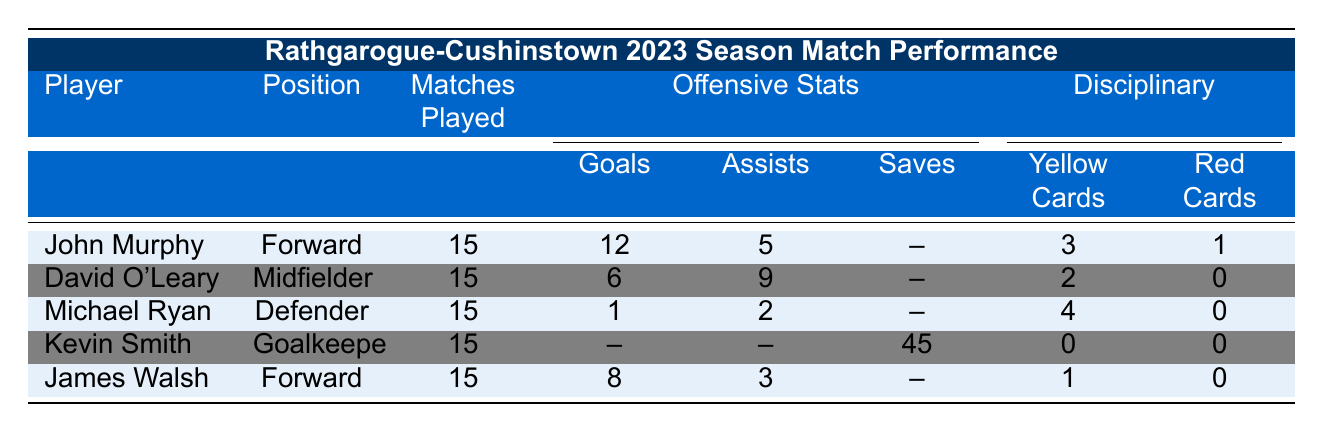What is the total number of goals scored by Rathgarogue-Cushinstown players? To find the total goals, we sum the number of goals from all players: John Murphy (12) + David O'Leary (6) + Michael Ryan (1) + James Walsh (8) = 27. Kevin Smith is a goalkeeper and does not score goals.
Answer: 27 Who received the most yellow cards in the team? Looking at the yellow cards for each player: John Murphy (3), David O'Leary (2), Michael Ryan (4), Kevin Smith (0), and James Walsh (1). Michael Ryan has the highest number with 4 yellow cards.
Answer: Michael Ryan How many assists does David O'Leary have compared to James Walsh? David O'Leary has 9 assists, while James Walsh has 3 assists. To compare, 9 - 3 = 6, so David has 6 more assists.
Answer: 6 What percentage of matches did John Murphy receive red cards in? John Murphy played 15 matches and received 1 red card. The percentage is calculated as (1 red card / 15 matches) * 100 = 6.67%.
Answer: 6.67% Did any player achieve a clean sheet? A clean sheet is only relevant for goalkeepers. Kevin Smith is the goalkeeper who achieved 5 clean sheets while playing 15 matches. Therefore, yes, he achieved clean sheets.
Answer: Yes Which player has the highest number of assists and how many? The highest assists go to David O'Leary with 9 assists. Comparing all players: John Murphy (5), David O'Leary (9), Michael Ryan (2), Kevin Smith (N/A for assists), and James Walsh (3), 9 is the highest.
Answer: 9 How many matches were played by the Defender Michael Ryan? According to the table, Michael Ryan played 15 matches.
Answer: 15 What is the ratio of goals to assists for John Murphy? John Murphy scored 12 goals and made 5 assists. The ratio is 12:5, which can also be expressed in its simplest form if needed, but it remains as this for now.
Answer: 12:5 Are there any players without any disciplinary records? The table shows Kevin Smith (goalkeeper) has 0 yellow cards and 0 red cards. Therefore, he has no disciplinary record.
Answer: Yes What is the total number of saves made by Kevin Smith? According to the table, Kevin Smith made a total of 45 saves during the season, as shown in his statistics.
Answer: 45 